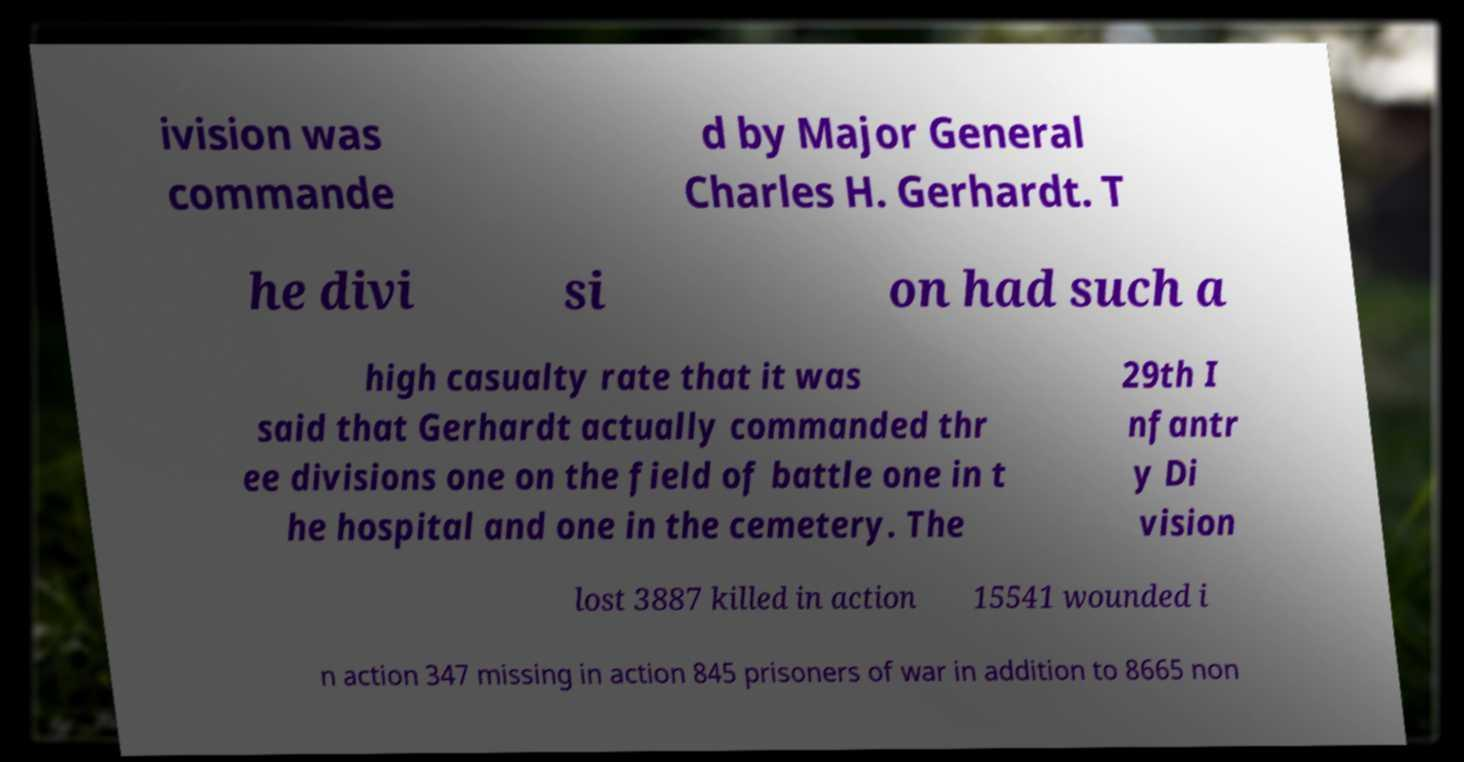Can you read and provide the text displayed in the image?This photo seems to have some interesting text. Can you extract and type it out for me? ivision was commande d by Major General Charles H. Gerhardt. T he divi si on had such a high casualty rate that it was said that Gerhardt actually commanded thr ee divisions one on the field of battle one in t he hospital and one in the cemetery. The 29th I nfantr y Di vision lost 3887 killed in action 15541 wounded i n action 347 missing in action 845 prisoners of war in addition to 8665 non 